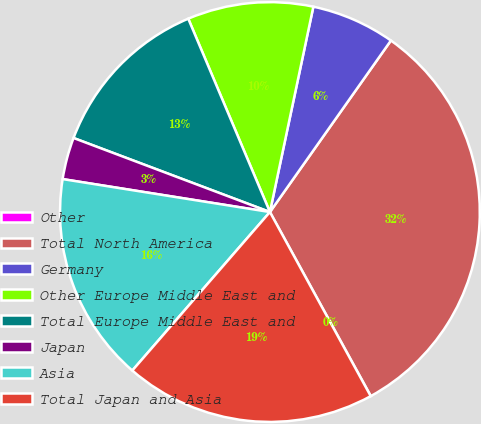Convert chart. <chart><loc_0><loc_0><loc_500><loc_500><pie_chart><fcel>Other<fcel>Total North America<fcel>Germany<fcel>Other Europe Middle East and<fcel>Total Europe Middle East and<fcel>Japan<fcel>Asia<fcel>Total Japan and Asia<nl><fcel>0.01%<fcel>32.24%<fcel>6.46%<fcel>9.68%<fcel>12.9%<fcel>3.23%<fcel>16.13%<fcel>19.35%<nl></chart> 